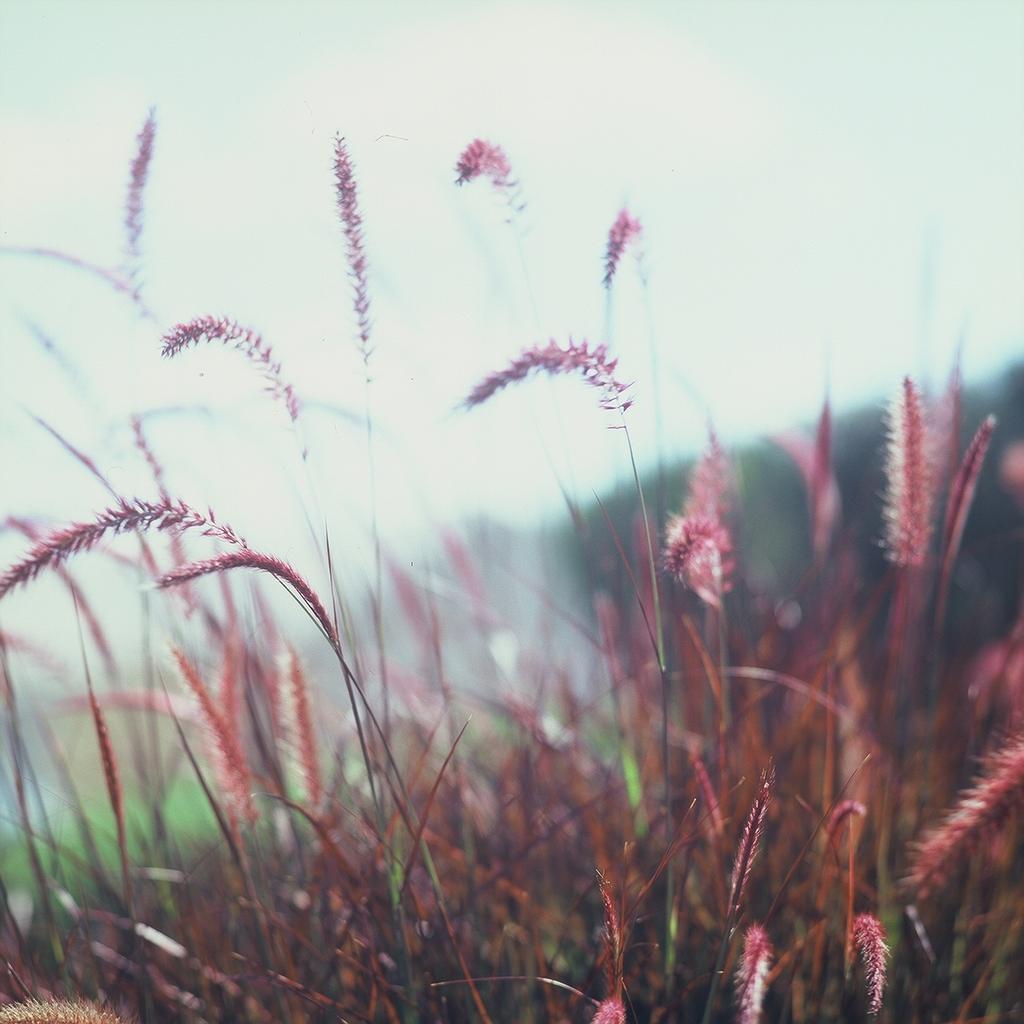How would you summarize this image in a sentence or two? In this image I can see the grass which is in maroon color. In the background I can see the trees and the sky. 